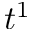<formula> <loc_0><loc_0><loc_500><loc_500>t ^ { 1 }</formula> 